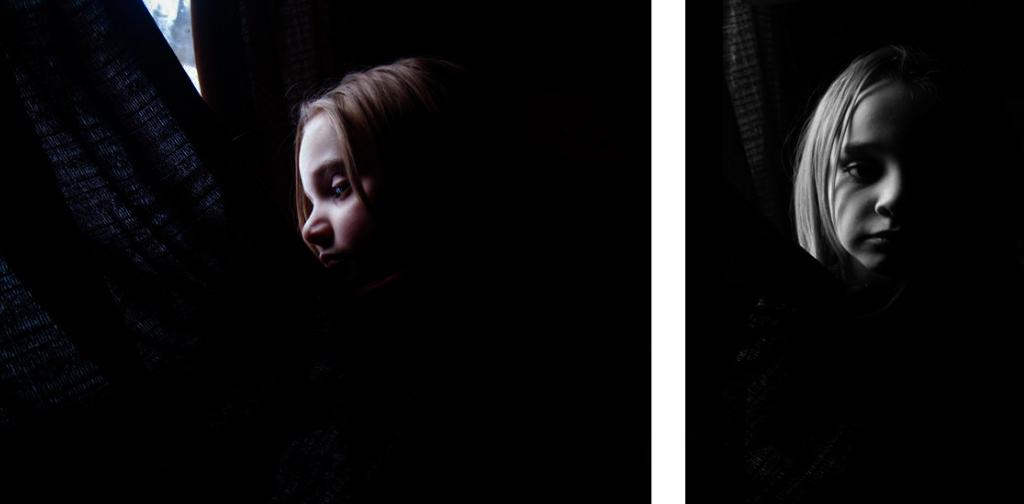What type of image is being described? The image is a collage. Are there any living beings in the image? Yes, there are persons in the image. What color are the objects mentioned in the image? The objects are black. What can be seen in the background on the left side of the image? There are trees in the background on the left side of the image. What is the title of the collage in the image? There is no title provided for the collage in the image. How many letters are visible in the image? The facts provided do not mention any letters in the image, so we cannot determine the number of letters. 